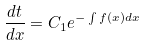Convert formula to latex. <formula><loc_0><loc_0><loc_500><loc_500>\frac { d t } { d x } = C _ { 1 } e ^ { - \int f ( x ) d x }</formula> 